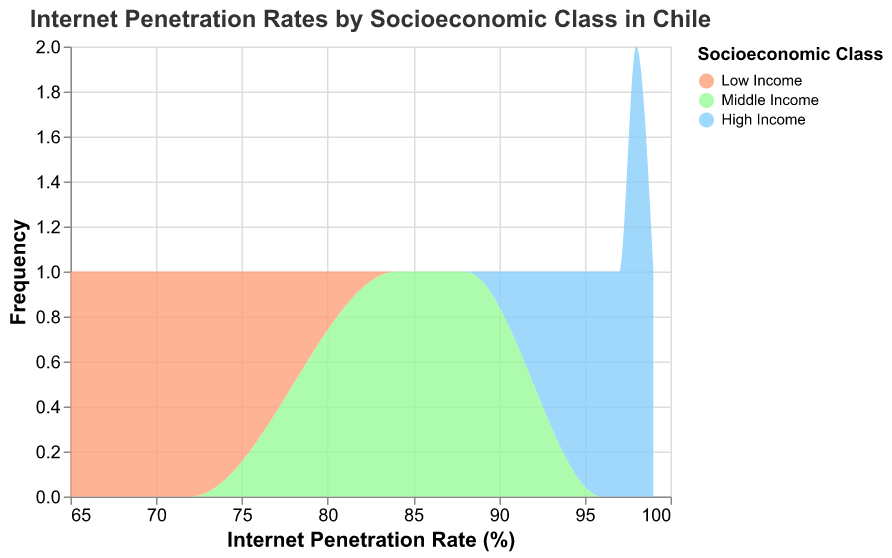What is the title of the figure? The title is usually placed at the top of the figure. Reading it directly helps identify the context of the data.
Answer: Internet Penetration Rates by Socioeconomic Class in Chile What are the socioeconomic classes represented in the figure? The classes are typically labeled in the legend and are color-coded in the figure. They can be directly read from there.
Answer: High Income, Middle Income, Low Income Which socioeconomic class has the highest internet penetration rate? The highest values on the x-axis within an area indicate the maximum internet penetration rate. This can be most clearly seen in the High Income class.
Answer: High Income What is the range of internet penetration rates for the Low Income class? The range can be deduced by looking at the spread of the values on the x-axis for the Low Income class area.
Answer: 65 to 72 How many data points are there for the High Income group? Count the individual values or marks within the High Income area. Each mark represents a data point.
Answer: 5 What is the average internet penetration rate for the Middle Income group? Sum the penetration rates for the Middle Income group and divide by the number of data points. This group has values of 87, 85, 88, 86, and 84. (87 + 85 + 88 + 86 + 84) / 5 = 86
Answer: 86 Compare the frequency of internet penetration rates between the High Income and Low Income groups. By analyzing the height of the areas under each segment, we can deduce the frequency distribution. High Income tends to have a tight, higher-frequency range, while Low Income has a lower, broader frequency.
Answer: High Income has more data points in a narrow range, Low Income has fewer data points in a wider range Which group shows the widest range of internet penetration rates? The range is the difference between the maximum and minimum values on the x-axis for each group. The Low Income group has the widest spread from 65 to 72.
Answer: Low Income What is the approximate difference in the highest internet penetration rates between Middle Income and Low Income classes? Identify the maximum penetration rate for both classes and subtract the Low Income's maximum from the Middle Income's maximum. The highest for Middle Income is 88, and for Low Income is 72, so the difference is 88 - 72.
Answer: 16 Which socioeconomic class has the lowest recorded internet penetration rate and what is it? Identify the lowest value on the x-axis within each area. The Low Income group has the lowest recorded rate, which is 65.
Answer: Low Income, 65 